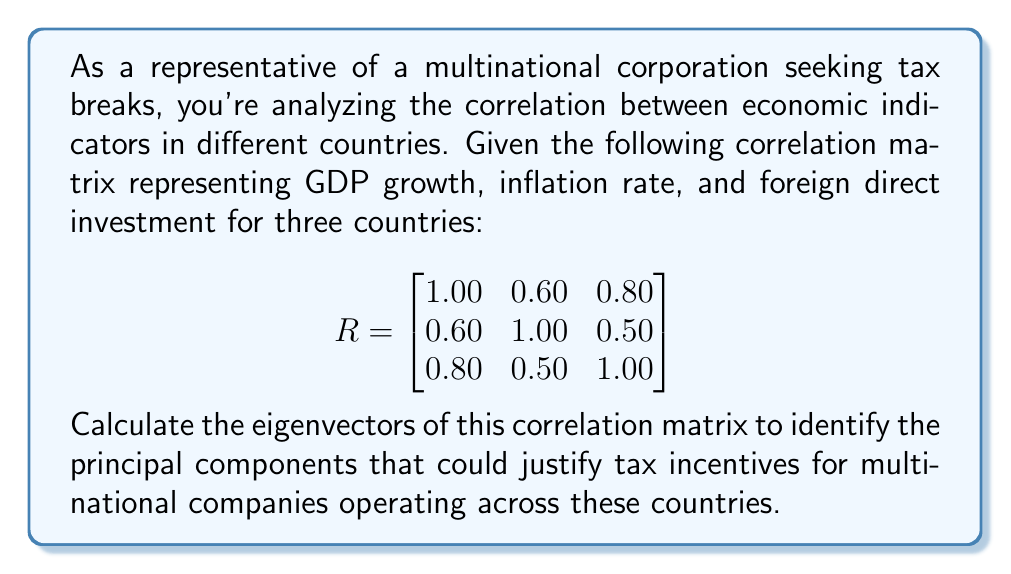Can you answer this question? To find the eigenvectors of the correlation matrix R, we follow these steps:

1) First, we need to solve the characteristic equation:
   $det(R - \lambda I) = 0$

2) Expand the determinant:
   $$\begin{vmatrix}
   1-\lambda & 0.60 & 0.80 \\
   0.60 & 1-\lambda & 0.50 \\
   0.80 & 0.50 & 1-\lambda
   \end{vmatrix} = 0$$

3) Solve the resulting cubic equation:
   $-\lambda^3 + 3\lambda^2 - 0.98\lambda - 0.488 = 0$

4) The solutions to this equation are the eigenvalues:
   $\lambda_1 \approx 2.173$, $\lambda_2 \approx 0.688$, $\lambda_3 \approx 0.139$

5) For each eigenvalue, solve $(R - \lambda I)v = 0$ to find the corresponding eigenvector:

   For $\lambda_1 \approx 2.173$:
   $$\begin{bmatrix}
   -1.173 & 0.60 & 0.80 \\
   0.60 & -1.173 & 0.50 \\
   0.80 & 0.50 & -1.173
   \end{bmatrix}\begin{bmatrix}v_1 \\ v_2 \\ v_3\end{bmatrix} = \begin{bmatrix}0 \\ 0 \\ 0\end{bmatrix}$$

   Solving this system gives $v_1 \approx [0.595, 0.458, 0.661]^T$

   Similarly, for $\lambda_2 \approx 0.688$ and $\lambda_3 \approx 0.139$, we get:
   $v_2 \approx [-0.543, 0.839, -0.044]^T$
   $v_3 \approx [0.593, 0.291, -0.750]^T$

6) Normalize each eigenvector to unit length.

The eigenvectors represent the principal components of the economic indicators across the countries, which could be used to justify tax incentives for multinational companies.
Answer: $v_1 \approx [0.595, 0.458, 0.661]^T$, $v_2 \approx [-0.543, 0.839, -0.044]^T$, $v_3 \approx [0.593, 0.291, -0.750]^T$ 